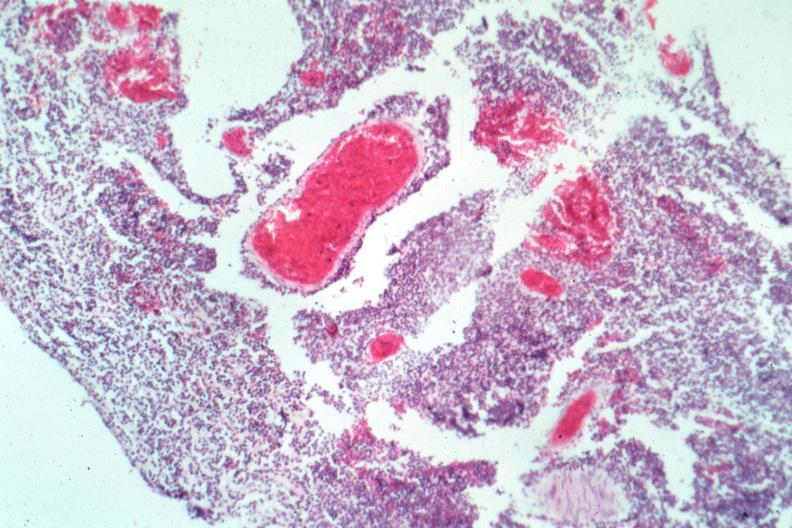does supernumerary digits show typical not the best micrograph?
Answer the question using a single word or phrase. No 